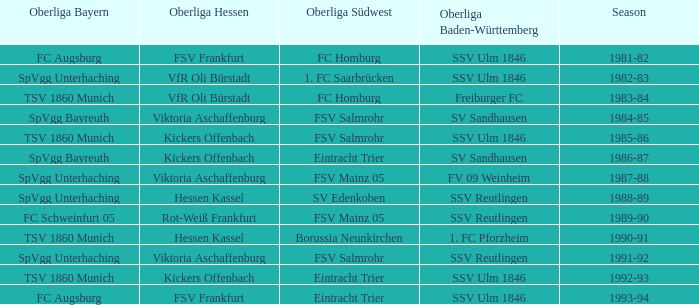Which oberliga baden-württemberg included an oberliga hessen with fsv frankfurt in the 1993-94 season? SSV Ulm 1846. 